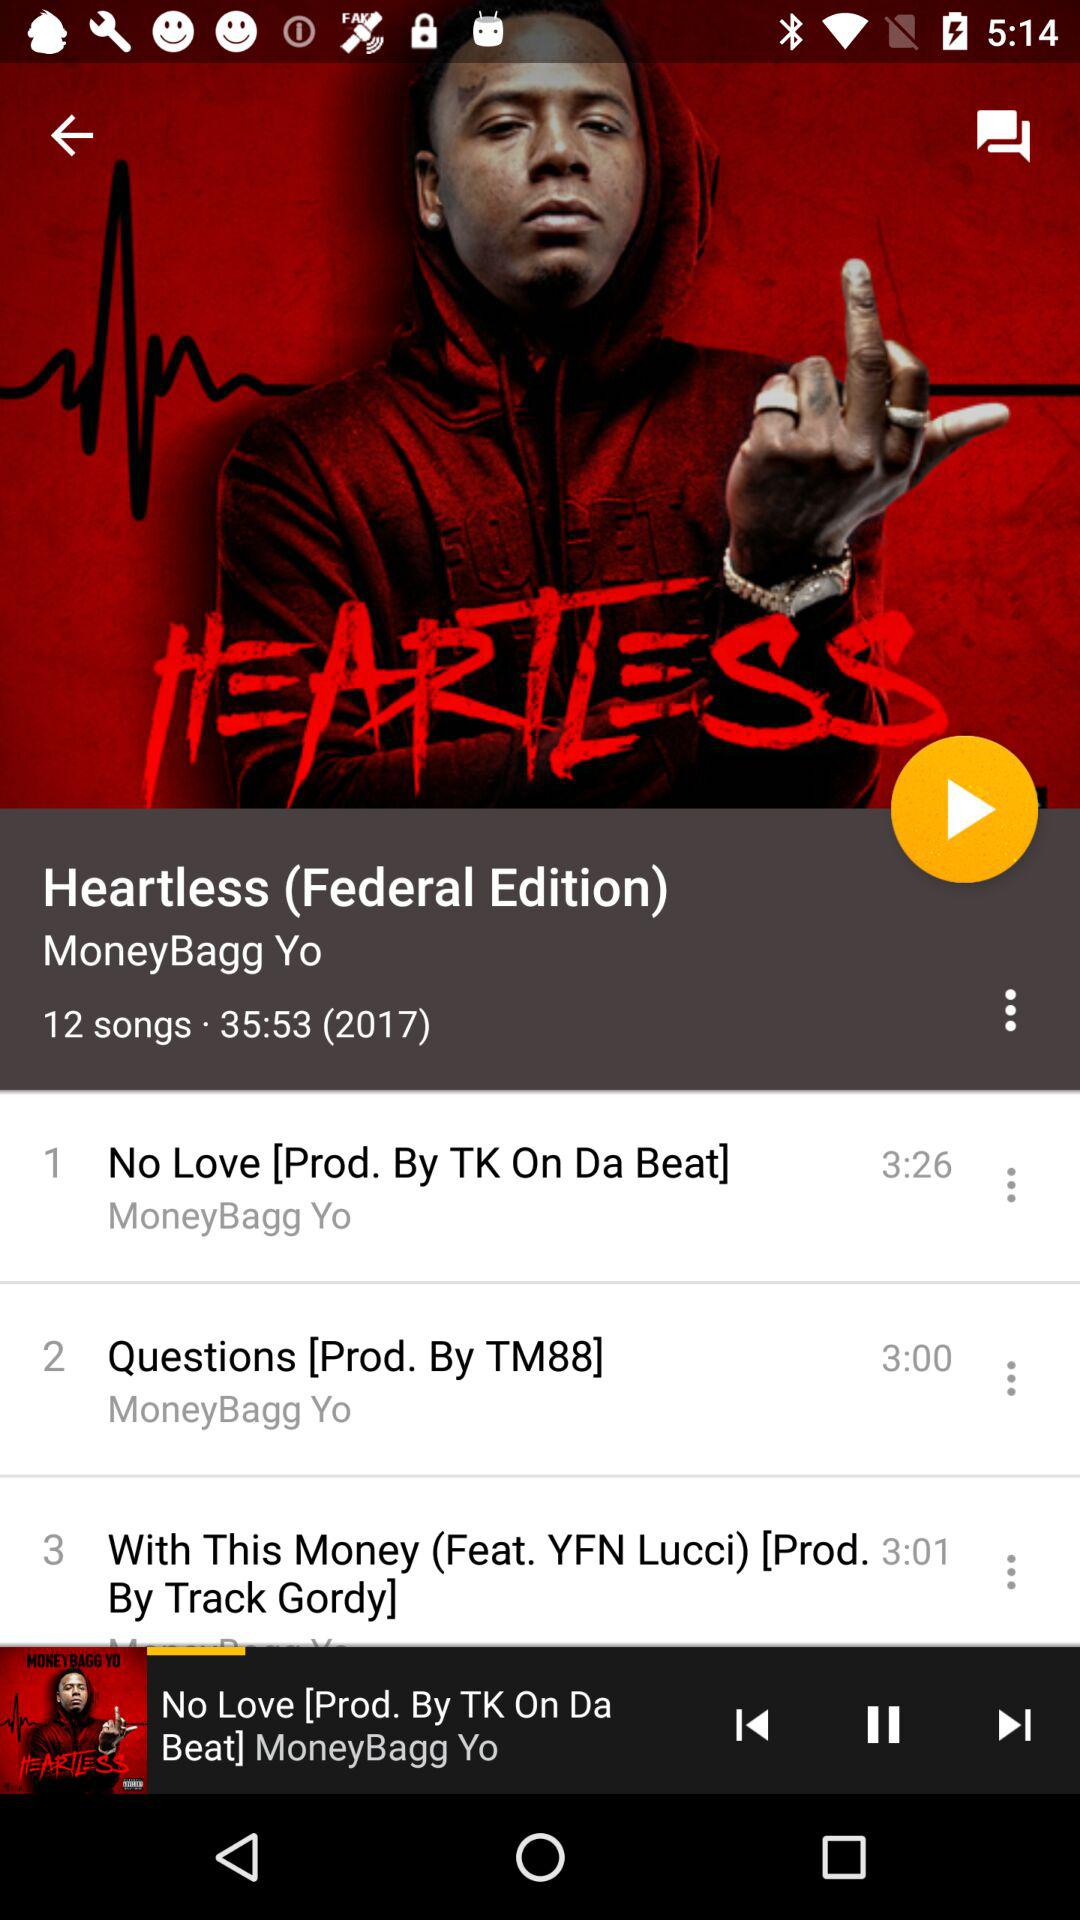How many songs are in the album?
Answer the question using a single word or phrase. 12 